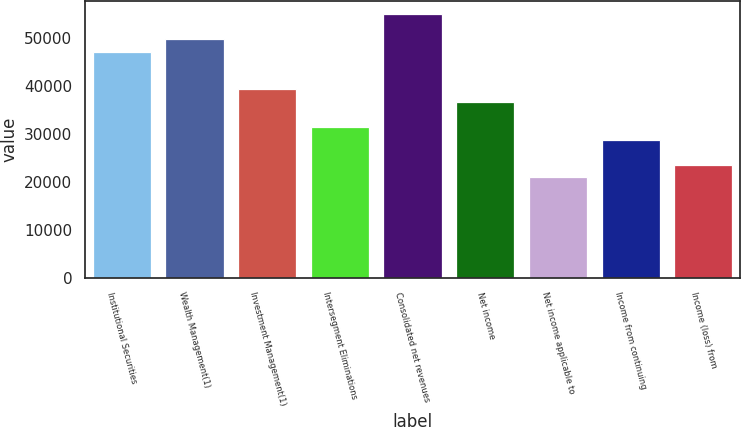Convert chart to OTSL. <chart><loc_0><loc_0><loc_500><loc_500><bar_chart><fcel>Institutional Securities<fcel>Wealth Management(1)<fcel>Investment Management(1)<fcel>Intersegment Eliminations<fcel>Consolidated net revenues<fcel>Net income<fcel>Net income applicable to<fcel>Income from continuing<fcel>Income (loss) from<nl><fcel>47120.4<fcel>49738.2<fcel>39267<fcel>31413.6<fcel>54973.8<fcel>36649.2<fcel>20942.4<fcel>28795.8<fcel>23560.2<nl></chart> 